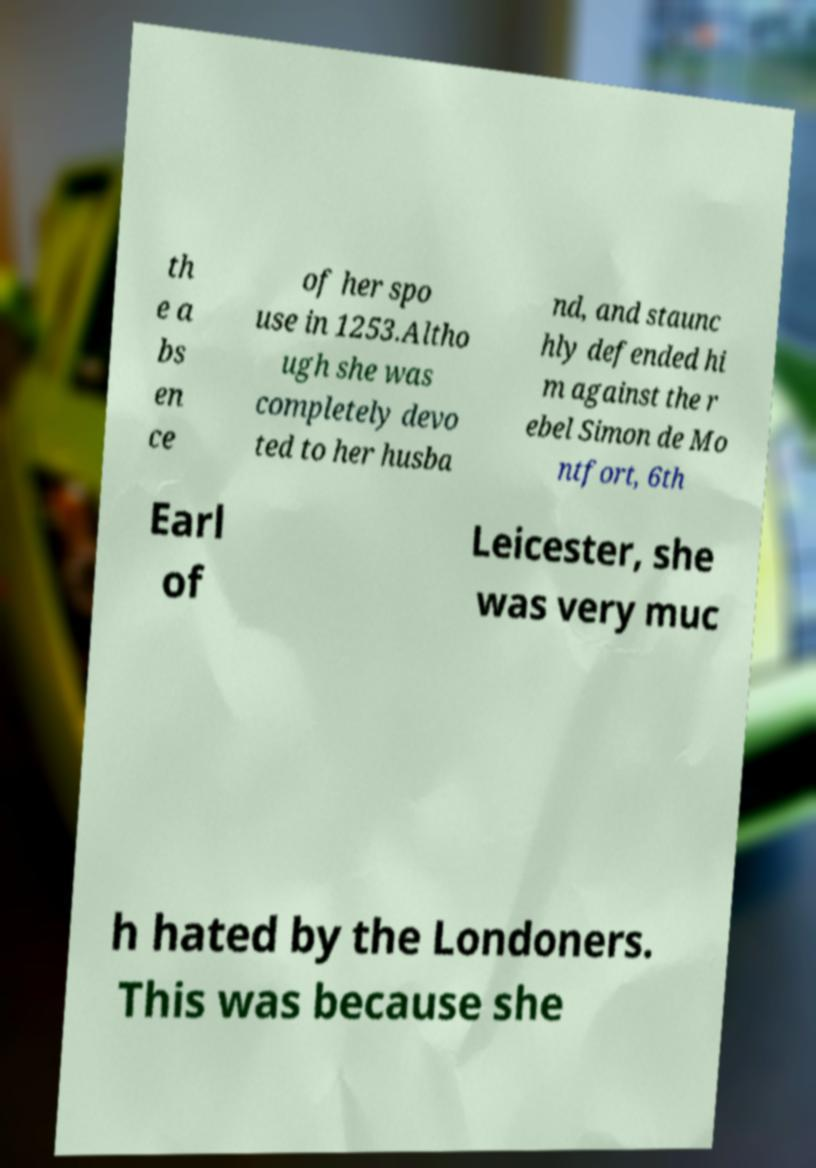Could you assist in decoding the text presented in this image and type it out clearly? th e a bs en ce of her spo use in 1253.Altho ugh she was completely devo ted to her husba nd, and staunc hly defended hi m against the r ebel Simon de Mo ntfort, 6th Earl of Leicester, she was very muc h hated by the Londoners. This was because she 